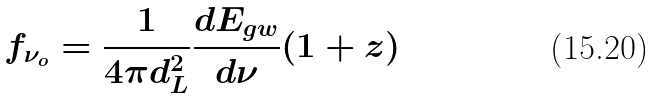<formula> <loc_0><loc_0><loc_500><loc_500>f _ { \nu _ { o } } = \frac { 1 } { 4 \pi d _ { L } ^ { 2 } } \frac { d E _ { g w } } { d \nu } ( 1 + z )</formula> 